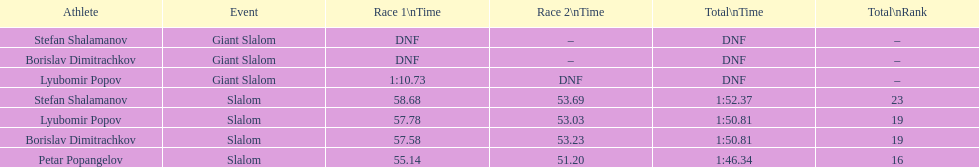Help me parse the entirety of this table. {'header': ['Athlete', 'Event', 'Race 1\\nTime', 'Race 2\\nTime', 'Total\\nTime', 'Total\\nRank'], 'rows': [['Stefan Shalamanov', 'Giant Slalom', 'DNF', '–', 'DNF', '–'], ['Borislav Dimitrachkov', 'Giant Slalom', 'DNF', '–', 'DNF', '–'], ['Lyubomir Popov', 'Giant Slalom', '1:10.73', 'DNF', 'DNF', '–'], ['Stefan Shalamanov', 'Slalom', '58.68', '53.69', '1:52.37', '23'], ['Lyubomir Popov', 'Slalom', '57.78', '53.03', '1:50.81', '19'], ['Borislav Dimitrachkov', 'Slalom', '57.58', '53.23', '1:50.81', '19'], ['Petar Popangelov', 'Slalom', '55.14', '51.20', '1:46.34', '16']]} What is stefan shalamanov's ranking in the slalom event? 23. 